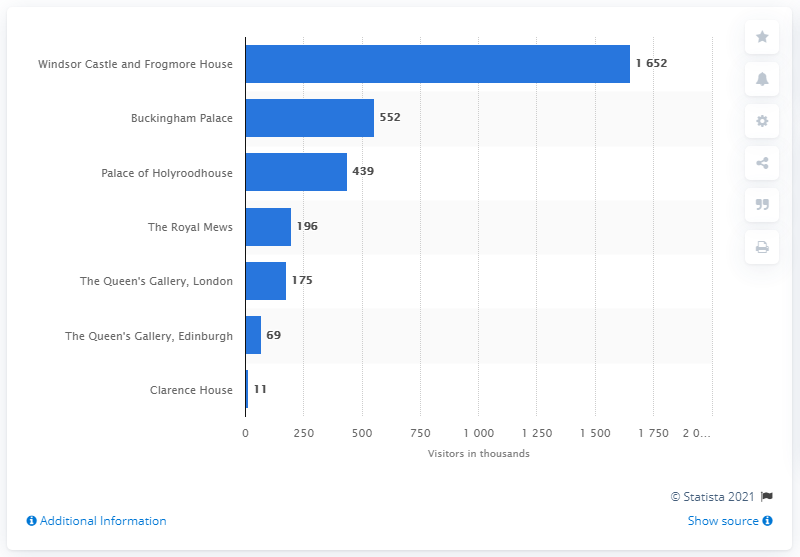List a handful of essential elements in this visual. The Royal Estate that received the most paid visitors in 2018/19 was Buckingham Palace. 